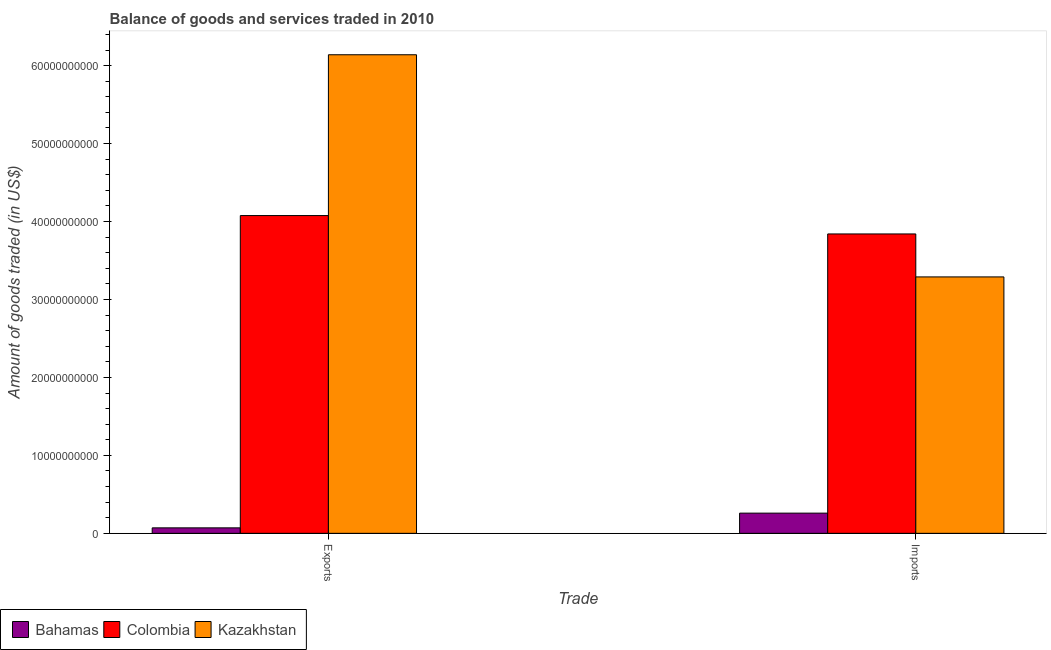How many different coloured bars are there?
Keep it short and to the point. 3. How many groups of bars are there?
Offer a terse response. 2. Are the number of bars on each tick of the X-axis equal?
Ensure brevity in your answer.  Yes. What is the label of the 1st group of bars from the left?
Your answer should be very brief. Exports. What is the amount of goods imported in Kazakhstan?
Your answer should be compact. 3.29e+1. Across all countries, what is the maximum amount of goods exported?
Ensure brevity in your answer.  6.14e+1. Across all countries, what is the minimum amount of goods imported?
Keep it short and to the point. 2.59e+09. In which country was the amount of goods exported maximum?
Your response must be concise. Kazakhstan. In which country was the amount of goods exported minimum?
Offer a terse response. Bahamas. What is the total amount of goods imported in the graph?
Provide a succinct answer. 7.39e+1. What is the difference between the amount of goods imported in Bahamas and that in Colombia?
Offer a very short reply. -3.58e+1. What is the difference between the amount of goods exported in Kazakhstan and the amount of goods imported in Colombia?
Your answer should be compact. 2.30e+1. What is the average amount of goods imported per country?
Your answer should be compact. 2.46e+1. What is the difference between the amount of goods exported and amount of goods imported in Kazakhstan?
Give a very brief answer. 2.85e+1. What is the ratio of the amount of goods imported in Kazakhstan to that in Bahamas?
Offer a very short reply. 12.69. Is the amount of goods imported in Bahamas less than that in Colombia?
Your response must be concise. Yes. In how many countries, is the amount of goods imported greater than the average amount of goods imported taken over all countries?
Your answer should be compact. 2. What does the 1st bar from the right in Exports represents?
Provide a succinct answer. Kazakhstan. How many bars are there?
Give a very brief answer. 6. Are all the bars in the graph horizontal?
Keep it short and to the point. No. How are the legend labels stacked?
Ensure brevity in your answer.  Horizontal. What is the title of the graph?
Keep it short and to the point. Balance of goods and services traded in 2010. Does "St. Martin (French part)" appear as one of the legend labels in the graph?
Your answer should be compact. No. What is the label or title of the X-axis?
Your response must be concise. Trade. What is the label or title of the Y-axis?
Your answer should be very brief. Amount of goods traded (in US$). What is the Amount of goods traded (in US$) of Bahamas in Exports?
Your response must be concise. 7.02e+08. What is the Amount of goods traded (in US$) in Colombia in Exports?
Your answer should be very brief. 4.08e+1. What is the Amount of goods traded (in US$) of Kazakhstan in Exports?
Your answer should be very brief. 6.14e+1. What is the Amount of goods traded (in US$) in Bahamas in Imports?
Offer a terse response. 2.59e+09. What is the Amount of goods traded (in US$) of Colombia in Imports?
Make the answer very short. 3.84e+1. What is the Amount of goods traded (in US$) of Kazakhstan in Imports?
Give a very brief answer. 3.29e+1. Across all Trade, what is the maximum Amount of goods traded (in US$) of Bahamas?
Your response must be concise. 2.59e+09. Across all Trade, what is the maximum Amount of goods traded (in US$) of Colombia?
Give a very brief answer. 4.08e+1. Across all Trade, what is the maximum Amount of goods traded (in US$) of Kazakhstan?
Your response must be concise. 6.14e+1. Across all Trade, what is the minimum Amount of goods traded (in US$) of Bahamas?
Offer a terse response. 7.02e+08. Across all Trade, what is the minimum Amount of goods traded (in US$) of Colombia?
Your answer should be very brief. 3.84e+1. Across all Trade, what is the minimum Amount of goods traded (in US$) of Kazakhstan?
Your answer should be compact. 3.29e+1. What is the total Amount of goods traded (in US$) of Bahamas in the graph?
Provide a short and direct response. 3.29e+09. What is the total Amount of goods traded (in US$) in Colombia in the graph?
Provide a short and direct response. 7.92e+1. What is the total Amount of goods traded (in US$) of Kazakhstan in the graph?
Provide a succinct answer. 9.43e+1. What is the difference between the Amount of goods traded (in US$) of Bahamas in Exports and that in Imports?
Make the answer very short. -1.89e+09. What is the difference between the Amount of goods traded (in US$) in Colombia in Exports and that in Imports?
Provide a short and direct response. 2.36e+09. What is the difference between the Amount of goods traded (in US$) of Kazakhstan in Exports and that in Imports?
Offer a very short reply. 2.85e+1. What is the difference between the Amount of goods traded (in US$) of Bahamas in Exports and the Amount of goods traded (in US$) of Colombia in Imports?
Offer a terse response. -3.77e+1. What is the difference between the Amount of goods traded (in US$) in Bahamas in Exports and the Amount of goods traded (in US$) in Kazakhstan in Imports?
Make the answer very short. -3.22e+1. What is the difference between the Amount of goods traded (in US$) of Colombia in Exports and the Amount of goods traded (in US$) of Kazakhstan in Imports?
Your answer should be very brief. 7.87e+09. What is the average Amount of goods traded (in US$) in Bahamas per Trade?
Make the answer very short. 1.65e+09. What is the average Amount of goods traded (in US$) of Colombia per Trade?
Provide a succinct answer. 3.96e+1. What is the average Amount of goods traded (in US$) in Kazakhstan per Trade?
Provide a succinct answer. 4.71e+1. What is the difference between the Amount of goods traded (in US$) of Bahamas and Amount of goods traded (in US$) of Colombia in Exports?
Offer a very short reply. -4.01e+1. What is the difference between the Amount of goods traded (in US$) of Bahamas and Amount of goods traded (in US$) of Kazakhstan in Exports?
Ensure brevity in your answer.  -6.07e+1. What is the difference between the Amount of goods traded (in US$) in Colombia and Amount of goods traded (in US$) in Kazakhstan in Exports?
Give a very brief answer. -2.06e+1. What is the difference between the Amount of goods traded (in US$) in Bahamas and Amount of goods traded (in US$) in Colombia in Imports?
Offer a terse response. -3.58e+1. What is the difference between the Amount of goods traded (in US$) of Bahamas and Amount of goods traded (in US$) of Kazakhstan in Imports?
Your answer should be compact. -3.03e+1. What is the difference between the Amount of goods traded (in US$) of Colombia and Amount of goods traded (in US$) of Kazakhstan in Imports?
Provide a short and direct response. 5.51e+09. What is the ratio of the Amount of goods traded (in US$) in Bahamas in Exports to that in Imports?
Offer a very short reply. 0.27. What is the ratio of the Amount of goods traded (in US$) of Colombia in Exports to that in Imports?
Your answer should be very brief. 1.06. What is the ratio of the Amount of goods traded (in US$) of Kazakhstan in Exports to that in Imports?
Keep it short and to the point. 1.87. What is the difference between the highest and the second highest Amount of goods traded (in US$) in Bahamas?
Your answer should be compact. 1.89e+09. What is the difference between the highest and the second highest Amount of goods traded (in US$) of Colombia?
Offer a very short reply. 2.36e+09. What is the difference between the highest and the second highest Amount of goods traded (in US$) in Kazakhstan?
Keep it short and to the point. 2.85e+1. What is the difference between the highest and the lowest Amount of goods traded (in US$) in Bahamas?
Make the answer very short. 1.89e+09. What is the difference between the highest and the lowest Amount of goods traded (in US$) in Colombia?
Your answer should be compact. 2.36e+09. What is the difference between the highest and the lowest Amount of goods traded (in US$) in Kazakhstan?
Offer a very short reply. 2.85e+1. 